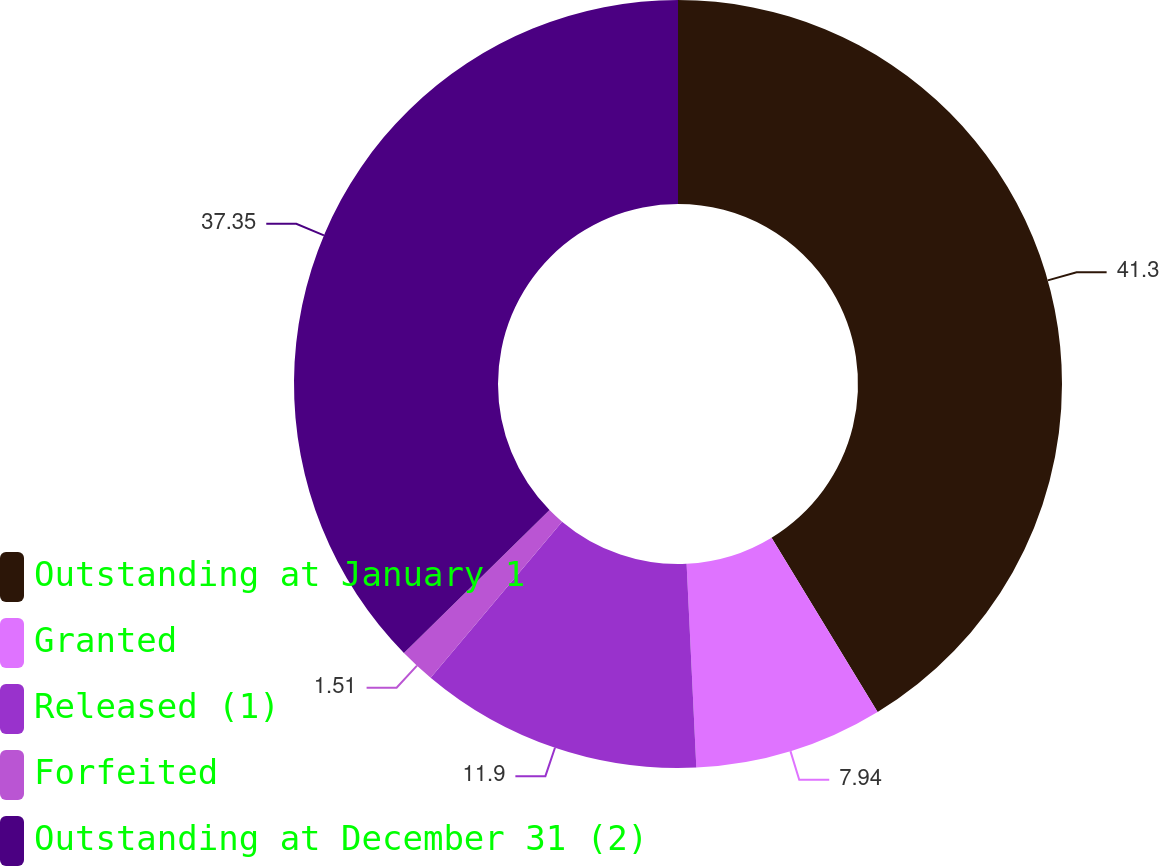<chart> <loc_0><loc_0><loc_500><loc_500><pie_chart><fcel>Outstanding at January 1<fcel>Granted<fcel>Released (1)<fcel>Forfeited<fcel>Outstanding at December 31 (2)<nl><fcel>41.3%<fcel>7.94%<fcel>11.9%<fcel>1.51%<fcel>37.35%<nl></chart> 